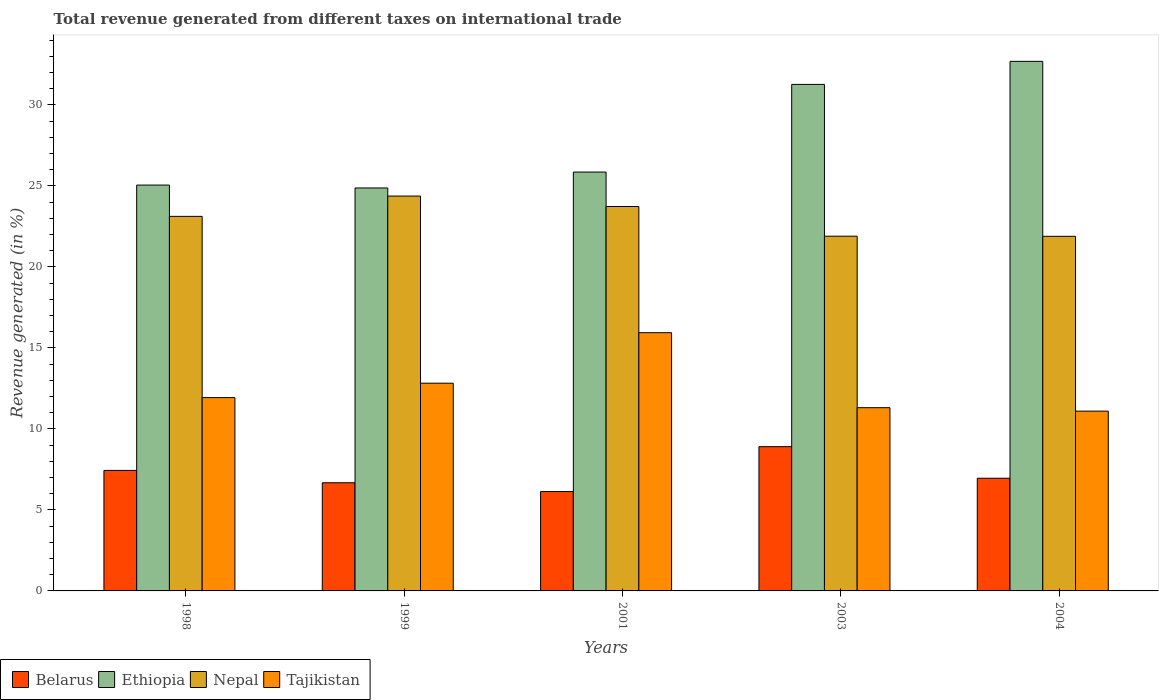How many groups of bars are there?
Provide a short and direct response. 5. Are the number of bars per tick equal to the number of legend labels?
Your answer should be very brief. Yes. Are the number of bars on each tick of the X-axis equal?
Provide a succinct answer. Yes. How many bars are there on the 3rd tick from the left?
Offer a very short reply. 4. In how many cases, is the number of bars for a given year not equal to the number of legend labels?
Offer a terse response. 0. What is the total revenue generated in Nepal in 2003?
Provide a short and direct response. 21.9. Across all years, what is the maximum total revenue generated in Nepal?
Your answer should be compact. 24.37. Across all years, what is the minimum total revenue generated in Tajikistan?
Keep it short and to the point. 11.1. In which year was the total revenue generated in Belarus maximum?
Ensure brevity in your answer.  2003. What is the total total revenue generated in Ethiopia in the graph?
Your response must be concise. 139.73. What is the difference between the total revenue generated in Belarus in 1999 and that in 2004?
Offer a terse response. -0.28. What is the difference between the total revenue generated in Tajikistan in 2001 and the total revenue generated in Belarus in 2004?
Your response must be concise. 8.98. What is the average total revenue generated in Nepal per year?
Offer a terse response. 23. In the year 2001, what is the difference between the total revenue generated in Ethiopia and total revenue generated in Nepal?
Your answer should be compact. 2.13. In how many years, is the total revenue generated in Nepal greater than 4 %?
Provide a succinct answer. 5. What is the ratio of the total revenue generated in Ethiopia in 1999 to that in 2001?
Your answer should be very brief. 0.96. Is the total revenue generated in Ethiopia in 1999 less than that in 2004?
Your answer should be compact. Yes. What is the difference between the highest and the second highest total revenue generated in Nepal?
Your answer should be very brief. 0.65. What is the difference between the highest and the lowest total revenue generated in Tajikistan?
Offer a very short reply. 4.84. In how many years, is the total revenue generated in Tajikistan greater than the average total revenue generated in Tajikistan taken over all years?
Keep it short and to the point. 2. Is the sum of the total revenue generated in Tajikistan in 2001 and 2003 greater than the maximum total revenue generated in Belarus across all years?
Your response must be concise. Yes. Is it the case that in every year, the sum of the total revenue generated in Tajikistan and total revenue generated in Nepal is greater than the sum of total revenue generated in Belarus and total revenue generated in Ethiopia?
Offer a terse response. No. What does the 4th bar from the left in 1999 represents?
Your answer should be compact. Tajikistan. What does the 4th bar from the right in 1999 represents?
Your answer should be compact. Belarus. How many bars are there?
Make the answer very short. 20. Are all the bars in the graph horizontal?
Give a very brief answer. No. What is the difference between two consecutive major ticks on the Y-axis?
Provide a short and direct response. 5. Are the values on the major ticks of Y-axis written in scientific E-notation?
Your response must be concise. No. How many legend labels are there?
Your answer should be compact. 4. What is the title of the graph?
Provide a succinct answer. Total revenue generated from different taxes on international trade. Does "Mozambique" appear as one of the legend labels in the graph?
Offer a terse response. No. What is the label or title of the X-axis?
Provide a succinct answer. Years. What is the label or title of the Y-axis?
Provide a short and direct response. Revenue generated (in %). What is the Revenue generated (in %) of Belarus in 1998?
Keep it short and to the point. 7.44. What is the Revenue generated (in %) of Ethiopia in 1998?
Offer a very short reply. 25.05. What is the Revenue generated (in %) in Nepal in 1998?
Offer a very short reply. 23.12. What is the Revenue generated (in %) in Tajikistan in 1998?
Provide a short and direct response. 11.93. What is the Revenue generated (in %) in Belarus in 1999?
Ensure brevity in your answer.  6.68. What is the Revenue generated (in %) of Ethiopia in 1999?
Your answer should be compact. 24.87. What is the Revenue generated (in %) of Nepal in 1999?
Provide a succinct answer. 24.37. What is the Revenue generated (in %) of Tajikistan in 1999?
Your answer should be compact. 12.82. What is the Revenue generated (in %) in Belarus in 2001?
Your answer should be very brief. 6.13. What is the Revenue generated (in %) in Ethiopia in 2001?
Make the answer very short. 25.86. What is the Revenue generated (in %) of Nepal in 2001?
Make the answer very short. 23.73. What is the Revenue generated (in %) of Tajikistan in 2001?
Offer a very short reply. 15.94. What is the Revenue generated (in %) in Belarus in 2003?
Your answer should be compact. 8.9. What is the Revenue generated (in %) of Ethiopia in 2003?
Provide a short and direct response. 31.27. What is the Revenue generated (in %) in Nepal in 2003?
Make the answer very short. 21.9. What is the Revenue generated (in %) of Tajikistan in 2003?
Ensure brevity in your answer.  11.31. What is the Revenue generated (in %) of Belarus in 2004?
Ensure brevity in your answer.  6.96. What is the Revenue generated (in %) of Ethiopia in 2004?
Offer a very short reply. 32.69. What is the Revenue generated (in %) of Nepal in 2004?
Provide a succinct answer. 21.89. What is the Revenue generated (in %) in Tajikistan in 2004?
Your answer should be very brief. 11.1. Across all years, what is the maximum Revenue generated (in %) of Belarus?
Make the answer very short. 8.9. Across all years, what is the maximum Revenue generated (in %) of Ethiopia?
Your response must be concise. 32.69. Across all years, what is the maximum Revenue generated (in %) of Nepal?
Make the answer very short. 24.37. Across all years, what is the maximum Revenue generated (in %) of Tajikistan?
Offer a terse response. 15.94. Across all years, what is the minimum Revenue generated (in %) in Belarus?
Offer a terse response. 6.13. Across all years, what is the minimum Revenue generated (in %) of Ethiopia?
Offer a very short reply. 24.87. Across all years, what is the minimum Revenue generated (in %) of Nepal?
Provide a succinct answer. 21.89. Across all years, what is the minimum Revenue generated (in %) of Tajikistan?
Make the answer very short. 11.1. What is the total Revenue generated (in %) in Belarus in the graph?
Provide a succinct answer. 36.11. What is the total Revenue generated (in %) of Ethiopia in the graph?
Offer a very short reply. 139.73. What is the total Revenue generated (in %) in Nepal in the graph?
Keep it short and to the point. 115.01. What is the total Revenue generated (in %) in Tajikistan in the graph?
Offer a very short reply. 63.1. What is the difference between the Revenue generated (in %) in Belarus in 1998 and that in 1999?
Provide a succinct answer. 0.76. What is the difference between the Revenue generated (in %) of Ethiopia in 1998 and that in 1999?
Provide a succinct answer. 0.18. What is the difference between the Revenue generated (in %) in Nepal in 1998 and that in 1999?
Offer a very short reply. -1.25. What is the difference between the Revenue generated (in %) in Tajikistan in 1998 and that in 1999?
Ensure brevity in your answer.  -0.89. What is the difference between the Revenue generated (in %) in Belarus in 1998 and that in 2001?
Your answer should be compact. 1.3. What is the difference between the Revenue generated (in %) of Ethiopia in 1998 and that in 2001?
Ensure brevity in your answer.  -0.8. What is the difference between the Revenue generated (in %) in Nepal in 1998 and that in 2001?
Your response must be concise. -0.61. What is the difference between the Revenue generated (in %) in Tajikistan in 1998 and that in 2001?
Your response must be concise. -4.01. What is the difference between the Revenue generated (in %) of Belarus in 1998 and that in 2003?
Provide a short and direct response. -1.47. What is the difference between the Revenue generated (in %) in Ethiopia in 1998 and that in 2003?
Offer a terse response. -6.21. What is the difference between the Revenue generated (in %) of Nepal in 1998 and that in 2003?
Offer a very short reply. 1.22. What is the difference between the Revenue generated (in %) in Tajikistan in 1998 and that in 2003?
Provide a short and direct response. 0.62. What is the difference between the Revenue generated (in %) in Belarus in 1998 and that in 2004?
Provide a short and direct response. 0.48. What is the difference between the Revenue generated (in %) in Ethiopia in 1998 and that in 2004?
Your answer should be compact. -7.64. What is the difference between the Revenue generated (in %) of Nepal in 1998 and that in 2004?
Your response must be concise. 1.23. What is the difference between the Revenue generated (in %) of Tajikistan in 1998 and that in 2004?
Offer a very short reply. 0.83. What is the difference between the Revenue generated (in %) in Belarus in 1999 and that in 2001?
Provide a succinct answer. 0.54. What is the difference between the Revenue generated (in %) of Ethiopia in 1999 and that in 2001?
Provide a succinct answer. -0.98. What is the difference between the Revenue generated (in %) in Nepal in 1999 and that in 2001?
Offer a terse response. 0.65. What is the difference between the Revenue generated (in %) in Tajikistan in 1999 and that in 2001?
Your answer should be very brief. -3.12. What is the difference between the Revenue generated (in %) in Belarus in 1999 and that in 2003?
Provide a succinct answer. -2.23. What is the difference between the Revenue generated (in %) in Ethiopia in 1999 and that in 2003?
Your response must be concise. -6.39. What is the difference between the Revenue generated (in %) of Nepal in 1999 and that in 2003?
Your answer should be very brief. 2.48. What is the difference between the Revenue generated (in %) of Tajikistan in 1999 and that in 2003?
Offer a very short reply. 1.51. What is the difference between the Revenue generated (in %) of Belarus in 1999 and that in 2004?
Ensure brevity in your answer.  -0.28. What is the difference between the Revenue generated (in %) of Ethiopia in 1999 and that in 2004?
Offer a terse response. -7.82. What is the difference between the Revenue generated (in %) of Nepal in 1999 and that in 2004?
Your response must be concise. 2.49. What is the difference between the Revenue generated (in %) of Tajikistan in 1999 and that in 2004?
Keep it short and to the point. 1.72. What is the difference between the Revenue generated (in %) in Belarus in 2001 and that in 2003?
Provide a short and direct response. -2.77. What is the difference between the Revenue generated (in %) of Ethiopia in 2001 and that in 2003?
Provide a succinct answer. -5.41. What is the difference between the Revenue generated (in %) of Nepal in 2001 and that in 2003?
Make the answer very short. 1.83. What is the difference between the Revenue generated (in %) in Tajikistan in 2001 and that in 2003?
Your response must be concise. 4.63. What is the difference between the Revenue generated (in %) in Belarus in 2001 and that in 2004?
Your response must be concise. -0.82. What is the difference between the Revenue generated (in %) of Ethiopia in 2001 and that in 2004?
Offer a very short reply. -6.83. What is the difference between the Revenue generated (in %) in Nepal in 2001 and that in 2004?
Make the answer very short. 1.84. What is the difference between the Revenue generated (in %) of Tajikistan in 2001 and that in 2004?
Your answer should be very brief. 4.84. What is the difference between the Revenue generated (in %) in Belarus in 2003 and that in 2004?
Your answer should be compact. 1.95. What is the difference between the Revenue generated (in %) in Ethiopia in 2003 and that in 2004?
Your answer should be compact. -1.42. What is the difference between the Revenue generated (in %) in Nepal in 2003 and that in 2004?
Make the answer very short. 0.01. What is the difference between the Revenue generated (in %) in Tajikistan in 2003 and that in 2004?
Your answer should be very brief. 0.21. What is the difference between the Revenue generated (in %) in Belarus in 1998 and the Revenue generated (in %) in Ethiopia in 1999?
Provide a short and direct response. -17.43. What is the difference between the Revenue generated (in %) of Belarus in 1998 and the Revenue generated (in %) of Nepal in 1999?
Ensure brevity in your answer.  -16.93. What is the difference between the Revenue generated (in %) in Belarus in 1998 and the Revenue generated (in %) in Tajikistan in 1999?
Offer a very short reply. -5.38. What is the difference between the Revenue generated (in %) of Ethiopia in 1998 and the Revenue generated (in %) of Nepal in 1999?
Your answer should be very brief. 0.68. What is the difference between the Revenue generated (in %) of Ethiopia in 1998 and the Revenue generated (in %) of Tajikistan in 1999?
Offer a very short reply. 12.23. What is the difference between the Revenue generated (in %) of Nepal in 1998 and the Revenue generated (in %) of Tajikistan in 1999?
Provide a short and direct response. 10.3. What is the difference between the Revenue generated (in %) of Belarus in 1998 and the Revenue generated (in %) of Ethiopia in 2001?
Make the answer very short. -18.42. What is the difference between the Revenue generated (in %) in Belarus in 1998 and the Revenue generated (in %) in Nepal in 2001?
Provide a short and direct response. -16.29. What is the difference between the Revenue generated (in %) in Belarus in 1998 and the Revenue generated (in %) in Tajikistan in 2001?
Make the answer very short. -8.5. What is the difference between the Revenue generated (in %) in Ethiopia in 1998 and the Revenue generated (in %) in Nepal in 2001?
Make the answer very short. 1.32. What is the difference between the Revenue generated (in %) of Ethiopia in 1998 and the Revenue generated (in %) of Tajikistan in 2001?
Give a very brief answer. 9.11. What is the difference between the Revenue generated (in %) in Nepal in 1998 and the Revenue generated (in %) in Tajikistan in 2001?
Offer a very short reply. 7.18. What is the difference between the Revenue generated (in %) in Belarus in 1998 and the Revenue generated (in %) in Ethiopia in 2003?
Offer a very short reply. -23.83. What is the difference between the Revenue generated (in %) of Belarus in 1998 and the Revenue generated (in %) of Nepal in 2003?
Give a very brief answer. -14.46. What is the difference between the Revenue generated (in %) in Belarus in 1998 and the Revenue generated (in %) in Tajikistan in 2003?
Give a very brief answer. -3.87. What is the difference between the Revenue generated (in %) in Ethiopia in 1998 and the Revenue generated (in %) in Nepal in 2003?
Provide a succinct answer. 3.16. What is the difference between the Revenue generated (in %) of Ethiopia in 1998 and the Revenue generated (in %) of Tajikistan in 2003?
Your answer should be compact. 13.74. What is the difference between the Revenue generated (in %) in Nepal in 1998 and the Revenue generated (in %) in Tajikistan in 2003?
Make the answer very short. 11.81. What is the difference between the Revenue generated (in %) in Belarus in 1998 and the Revenue generated (in %) in Ethiopia in 2004?
Your answer should be compact. -25.25. What is the difference between the Revenue generated (in %) of Belarus in 1998 and the Revenue generated (in %) of Nepal in 2004?
Provide a short and direct response. -14.45. What is the difference between the Revenue generated (in %) of Belarus in 1998 and the Revenue generated (in %) of Tajikistan in 2004?
Offer a terse response. -3.66. What is the difference between the Revenue generated (in %) in Ethiopia in 1998 and the Revenue generated (in %) in Nepal in 2004?
Your answer should be very brief. 3.16. What is the difference between the Revenue generated (in %) of Ethiopia in 1998 and the Revenue generated (in %) of Tajikistan in 2004?
Your response must be concise. 13.95. What is the difference between the Revenue generated (in %) of Nepal in 1998 and the Revenue generated (in %) of Tajikistan in 2004?
Provide a short and direct response. 12.02. What is the difference between the Revenue generated (in %) in Belarus in 1999 and the Revenue generated (in %) in Ethiopia in 2001?
Your response must be concise. -19.18. What is the difference between the Revenue generated (in %) in Belarus in 1999 and the Revenue generated (in %) in Nepal in 2001?
Provide a succinct answer. -17.05. What is the difference between the Revenue generated (in %) of Belarus in 1999 and the Revenue generated (in %) of Tajikistan in 2001?
Offer a terse response. -9.26. What is the difference between the Revenue generated (in %) of Ethiopia in 1999 and the Revenue generated (in %) of Nepal in 2001?
Provide a succinct answer. 1.14. What is the difference between the Revenue generated (in %) in Ethiopia in 1999 and the Revenue generated (in %) in Tajikistan in 2001?
Provide a succinct answer. 8.93. What is the difference between the Revenue generated (in %) of Nepal in 1999 and the Revenue generated (in %) of Tajikistan in 2001?
Ensure brevity in your answer.  8.43. What is the difference between the Revenue generated (in %) of Belarus in 1999 and the Revenue generated (in %) of Ethiopia in 2003?
Make the answer very short. -24.59. What is the difference between the Revenue generated (in %) of Belarus in 1999 and the Revenue generated (in %) of Nepal in 2003?
Your response must be concise. -15.22. What is the difference between the Revenue generated (in %) of Belarus in 1999 and the Revenue generated (in %) of Tajikistan in 2003?
Offer a terse response. -4.63. What is the difference between the Revenue generated (in %) of Ethiopia in 1999 and the Revenue generated (in %) of Nepal in 2003?
Ensure brevity in your answer.  2.98. What is the difference between the Revenue generated (in %) of Ethiopia in 1999 and the Revenue generated (in %) of Tajikistan in 2003?
Ensure brevity in your answer.  13.56. What is the difference between the Revenue generated (in %) in Nepal in 1999 and the Revenue generated (in %) in Tajikistan in 2003?
Provide a short and direct response. 13.06. What is the difference between the Revenue generated (in %) in Belarus in 1999 and the Revenue generated (in %) in Ethiopia in 2004?
Your answer should be very brief. -26.01. What is the difference between the Revenue generated (in %) in Belarus in 1999 and the Revenue generated (in %) in Nepal in 2004?
Keep it short and to the point. -15.21. What is the difference between the Revenue generated (in %) of Belarus in 1999 and the Revenue generated (in %) of Tajikistan in 2004?
Your answer should be very brief. -4.42. What is the difference between the Revenue generated (in %) in Ethiopia in 1999 and the Revenue generated (in %) in Nepal in 2004?
Provide a succinct answer. 2.98. What is the difference between the Revenue generated (in %) in Ethiopia in 1999 and the Revenue generated (in %) in Tajikistan in 2004?
Your response must be concise. 13.78. What is the difference between the Revenue generated (in %) of Nepal in 1999 and the Revenue generated (in %) of Tajikistan in 2004?
Your answer should be compact. 13.28. What is the difference between the Revenue generated (in %) of Belarus in 2001 and the Revenue generated (in %) of Ethiopia in 2003?
Offer a very short reply. -25.13. What is the difference between the Revenue generated (in %) of Belarus in 2001 and the Revenue generated (in %) of Nepal in 2003?
Make the answer very short. -15.76. What is the difference between the Revenue generated (in %) of Belarus in 2001 and the Revenue generated (in %) of Tajikistan in 2003?
Keep it short and to the point. -5.18. What is the difference between the Revenue generated (in %) in Ethiopia in 2001 and the Revenue generated (in %) in Nepal in 2003?
Offer a very short reply. 3.96. What is the difference between the Revenue generated (in %) in Ethiopia in 2001 and the Revenue generated (in %) in Tajikistan in 2003?
Make the answer very short. 14.55. What is the difference between the Revenue generated (in %) in Nepal in 2001 and the Revenue generated (in %) in Tajikistan in 2003?
Offer a very short reply. 12.42. What is the difference between the Revenue generated (in %) in Belarus in 2001 and the Revenue generated (in %) in Ethiopia in 2004?
Offer a very short reply. -26.55. What is the difference between the Revenue generated (in %) in Belarus in 2001 and the Revenue generated (in %) in Nepal in 2004?
Your answer should be very brief. -15.75. What is the difference between the Revenue generated (in %) of Belarus in 2001 and the Revenue generated (in %) of Tajikistan in 2004?
Give a very brief answer. -4.96. What is the difference between the Revenue generated (in %) of Ethiopia in 2001 and the Revenue generated (in %) of Nepal in 2004?
Your answer should be very brief. 3.97. What is the difference between the Revenue generated (in %) in Ethiopia in 2001 and the Revenue generated (in %) in Tajikistan in 2004?
Offer a terse response. 14.76. What is the difference between the Revenue generated (in %) in Nepal in 2001 and the Revenue generated (in %) in Tajikistan in 2004?
Keep it short and to the point. 12.63. What is the difference between the Revenue generated (in %) of Belarus in 2003 and the Revenue generated (in %) of Ethiopia in 2004?
Keep it short and to the point. -23.78. What is the difference between the Revenue generated (in %) of Belarus in 2003 and the Revenue generated (in %) of Nepal in 2004?
Offer a very short reply. -12.98. What is the difference between the Revenue generated (in %) in Belarus in 2003 and the Revenue generated (in %) in Tajikistan in 2004?
Keep it short and to the point. -2.19. What is the difference between the Revenue generated (in %) in Ethiopia in 2003 and the Revenue generated (in %) in Nepal in 2004?
Keep it short and to the point. 9.38. What is the difference between the Revenue generated (in %) in Ethiopia in 2003 and the Revenue generated (in %) in Tajikistan in 2004?
Your response must be concise. 20.17. What is the difference between the Revenue generated (in %) in Nepal in 2003 and the Revenue generated (in %) in Tajikistan in 2004?
Keep it short and to the point. 10.8. What is the average Revenue generated (in %) in Belarus per year?
Your answer should be very brief. 7.22. What is the average Revenue generated (in %) of Ethiopia per year?
Ensure brevity in your answer.  27.95. What is the average Revenue generated (in %) in Nepal per year?
Your answer should be very brief. 23. What is the average Revenue generated (in %) of Tajikistan per year?
Provide a short and direct response. 12.62. In the year 1998, what is the difference between the Revenue generated (in %) of Belarus and Revenue generated (in %) of Ethiopia?
Ensure brevity in your answer.  -17.61. In the year 1998, what is the difference between the Revenue generated (in %) of Belarus and Revenue generated (in %) of Nepal?
Your answer should be compact. -15.68. In the year 1998, what is the difference between the Revenue generated (in %) of Belarus and Revenue generated (in %) of Tajikistan?
Your answer should be compact. -4.49. In the year 1998, what is the difference between the Revenue generated (in %) in Ethiopia and Revenue generated (in %) in Nepal?
Provide a succinct answer. 1.93. In the year 1998, what is the difference between the Revenue generated (in %) of Ethiopia and Revenue generated (in %) of Tajikistan?
Ensure brevity in your answer.  13.12. In the year 1998, what is the difference between the Revenue generated (in %) of Nepal and Revenue generated (in %) of Tajikistan?
Offer a terse response. 11.19. In the year 1999, what is the difference between the Revenue generated (in %) in Belarus and Revenue generated (in %) in Ethiopia?
Your answer should be compact. -18.2. In the year 1999, what is the difference between the Revenue generated (in %) in Belarus and Revenue generated (in %) in Nepal?
Give a very brief answer. -17.7. In the year 1999, what is the difference between the Revenue generated (in %) in Belarus and Revenue generated (in %) in Tajikistan?
Ensure brevity in your answer.  -6.15. In the year 1999, what is the difference between the Revenue generated (in %) in Ethiopia and Revenue generated (in %) in Nepal?
Your answer should be very brief. 0.5. In the year 1999, what is the difference between the Revenue generated (in %) of Ethiopia and Revenue generated (in %) of Tajikistan?
Make the answer very short. 12.05. In the year 1999, what is the difference between the Revenue generated (in %) in Nepal and Revenue generated (in %) in Tajikistan?
Make the answer very short. 11.55. In the year 2001, what is the difference between the Revenue generated (in %) of Belarus and Revenue generated (in %) of Ethiopia?
Offer a very short reply. -19.72. In the year 2001, what is the difference between the Revenue generated (in %) of Belarus and Revenue generated (in %) of Nepal?
Keep it short and to the point. -17.59. In the year 2001, what is the difference between the Revenue generated (in %) of Belarus and Revenue generated (in %) of Tajikistan?
Your answer should be very brief. -9.8. In the year 2001, what is the difference between the Revenue generated (in %) in Ethiopia and Revenue generated (in %) in Nepal?
Your answer should be compact. 2.13. In the year 2001, what is the difference between the Revenue generated (in %) of Ethiopia and Revenue generated (in %) of Tajikistan?
Provide a succinct answer. 9.92. In the year 2001, what is the difference between the Revenue generated (in %) in Nepal and Revenue generated (in %) in Tajikistan?
Keep it short and to the point. 7.79. In the year 2003, what is the difference between the Revenue generated (in %) in Belarus and Revenue generated (in %) in Ethiopia?
Ensure brevity in your answer.  -22.36. In the year 2003, what is the difference between the Revenue generated (in %) in Belarus and Revenue generated (in %) in Nepal?
Give a very brief answer. -12.99. In the year 2003, what is the difference between the Revenue generated (in %) in Belarus and Revenue generated (in %) in Tajikistan?
Ensure brevity in your answer.  -2.41. In the year 2003, what is the difference between the Revenue generated (in %) of Ethiopia and Revenue generated (in %) of Nepal?
Your response must be concise. 9.37. In the year 2003, what is the difference between the Revenue generated (in %) of Ethiopia and Revenue generated (in %) of Tajikistan?
Provide a succinct answer. 19.96. In the year 2003, what is the difference between the Revenue generated (in %) of Nepal and Revenue generated (in %) of Tajikistan?
Offer a very short reply. 10.59. In the year 2004, what is the difference between the Revenue generated (in %) in Belarus and Revenue generated (in %) in Ethiopia?
Ensure brevity in your answer.  -25.73. In the year 2004, what is the difference between the Revenue generated (in %) of Belarus and Revenue generated (in %) of Nepal?
Ensure brevity in your answer.  -14.93. In the year 2004, what is the difference between the Revenue generated (in %) in Belarus and Revenue generated (in %) in Tajikistan?
Offer a very short reply. -4.14. In the year 2004, what is the difference between the Revenue generated (in %) in Ethiopia and Revenue generated (in %) in Nepal?
Your answer should be very brief. 10.8. In the year 2004, what is the difference between the Revenue generated (in %) of Ethiopia and Revenue generated (in %) of Tajikistan?
Ensure brevity in your answer.  21.59. In the year 2004, what is the difference between the Revenue generated (in %) of Nepal and Revenue generated (in %) of Tajikistan?
Give a very brief answer. 10.79. What is the ratio of the Revenue generated (in %) in Belarus in 1998 to that in 1999?
Your answer should be compact. 1.11. What is the ratio of the Revenue generated (in %) of Nepal in 1998 to that in 1999?
Provide a succinct answer. 0.95. What is the ratio of the Revenue generated (in %) in Tajikistan in 1998 to that in 1999?
Your answer should be very brief. 0.93. What is the ratio of the Revenue generated (in %) in Belarus in 1998 to that in 2001?
Keep it short and to the point. 1.21. What is the ratio of the Revenue generated (in %) in Ethiopia in 1998 to that in 2001?
Your answer should be compact. 0.97. What is the ratio of the Revenue generated (in %) in Nepal in 1998 to that in 2001?
Make the answer very short. 0.97. What is the ratio of the Revenue generated (in %) of Tajikistan in 1998 to that in 2001?
Offer a very short reply. 0.75. What is the ratio of the Revenue generated (in %) of Belarus in 1998 to that in 2003?
Your response must be concise. 0.84. What is the ratio of the Revenue generated (in %) of Ethiopia in 1998 to that in 2003?
Your answer should be compact. 0.8. What is the ratio of the Revenue generated (in %) of Nepal in 1998 to that in 2003?
Offer a very short reply. 1.06. What is the ratio of the Revenue generated (in %) in Tajikistan in 1998 to that in 2003?
Ensure brevity in your answer.  1.05. What is the ratio of the Revenue generated (in %) of Belarus in 1998 to that in 2004?
Give a very brief answer. 1.07. What is the ratio of the Revenue generated (in %) in Ethiopia in 1998 to that in 2004?
Offer a very short reply. 0.77. What is the ratio of the Revenue generated (in %) of Nepal in 1998 to that in 2004?
Give a very brief answer. 1.06. What is the ratio of the Revenue generated (in %) in Tajikistan in 1998 to that in 2004?
Your answer should be compact. 1.08. What is the ratio of the Revenue generated (in %) of Belarus in 1999 to that in 2001?
Your response must be concise. 1.09. What is the ratio of the Revenue generated (in %) of Nepal in 1999 to that in 2001?
Offer a very short reply. 1.03. What is the ratio of the Revenue generated (in %) of Tajikistan in 1999 to that in 2001?
Offer a terse response. 0.8. What is the ratio of the Revenue generated (in %) of Belarus in 1999 to that in 2003?
Your response must be concise. 0.75. What is the ratio of the Revenue generated (in %) in Ethiopia in 1999 to that in 2003?
Your answer should be very brief. 0.8. What is the ratio of the Revenue generated (in %) in Nepal in 1999 to that in 2003?
Give a very brief answer. 1.11. What is the ratio of the Revenue generated (in %) in Tajikistan in 1999 to that in 2003?
Provide a succinct answer. 1.13. What is the ratio of the Revenue generated (in %) of Belarus in 1999 to that in 2004?
Give a very brief answer. 0.96. What is the ratio of the Revenue generated (in %) in Ethiopia in 1999 to that in 2004?
Make the answer very short. 0.76. What is the ratio of the Revenue generated (in %) in Nepal in 1999 to that in 2004?
Your answer should be compact. 1.11. What is the ratio of the Revenue generated (in %) of Tajikistan in 1999 to that in 2004?
Provide a succinct answer. 1.16. What is the ratio of the Revenue generated (in %) in Belarus in 2001 to that in 2003?
Your answer should be very brief. 0.69. What is the ratio of the Revenue generated (in %) of Ethiopia in 2001 to that in 2003?
Offer a very short reply. 0.83. What is the ratio of the Revenue generated (in %) of Nepal in 2001 to that in 2003?
Your answer should be very brief. 1.08. What is the ratio of the Revenue generated (in %) in Tajikistan in 2001 to that in 2003?
Provide a succinct answer. 1.41. What is the ratio of the Revenue generated (in %) of Belarus in 2001 to that in 2004?
Keep it short and to the point. 0.88. What is the ratio of the Revenue generated (in %) in Ethiopia in 2001 to that in 2004?
Make the answer very short. 0.79. What is the ratio of the Revenue generated (in %) in Nepal in 2001 to that in 2004?
Your response must be concise. 1.08. What is the ratio of the Revenue generated (in %) of Tajikistan in 2001 to that in 2004?
Provide a succinct answer. 1.44. What is the ratio of the Revenue generated (in %) in Belarus in 2003 to that in 2004?
Your answer should be compact. 1.28. What is the ratio of the Revenue generated (in %) of Ethiopia in 2003 to that in 2004?
Ensure brevity in your answer.  0.96. What is the ratio of the Revenue generated (in %) in Nepal in 2003 to that in 2004?
Give a very brief answer. 1. What is the ratio of the Revenue generated (in %) of Tajikistan in 2003 to that in 2004?
Give a very brief answer. 1.02. What is the difference between the highest and the second highest Revenue generated (in %) in Belarus?
Ensure brevity in your answer.  1.47. What is the difference between the highest and the second highest Revenue generated (in %) in Ethiopia?
Your answer should be compact. 1.42. What is the difference between the highest and the second highest Revenue generated (in %) of Nepal?
Make the answer very short. 0.65. What is the difference between the highest and the second highest Revenue generated (in %) in Tajikistan?
Ensure brevity in your answer.  3.12. What is the difference between the highest and the lowest Revenue generated (in %) of Belarus?
Provide a succinct answer. 2.77. What is the difference between the highest and the lowest Revenue generated (in %) of Ethiopia?
Give a very brief answer. 7.82. What is the difference between the highest and the lowest Revenue generated (in %) in Nepal?
Offer a terse response. 2.49. What is the difference between the highest and the lowest Revenue generated (in %) in Tajikistan?
Your answer should be very brief. 4.84. 